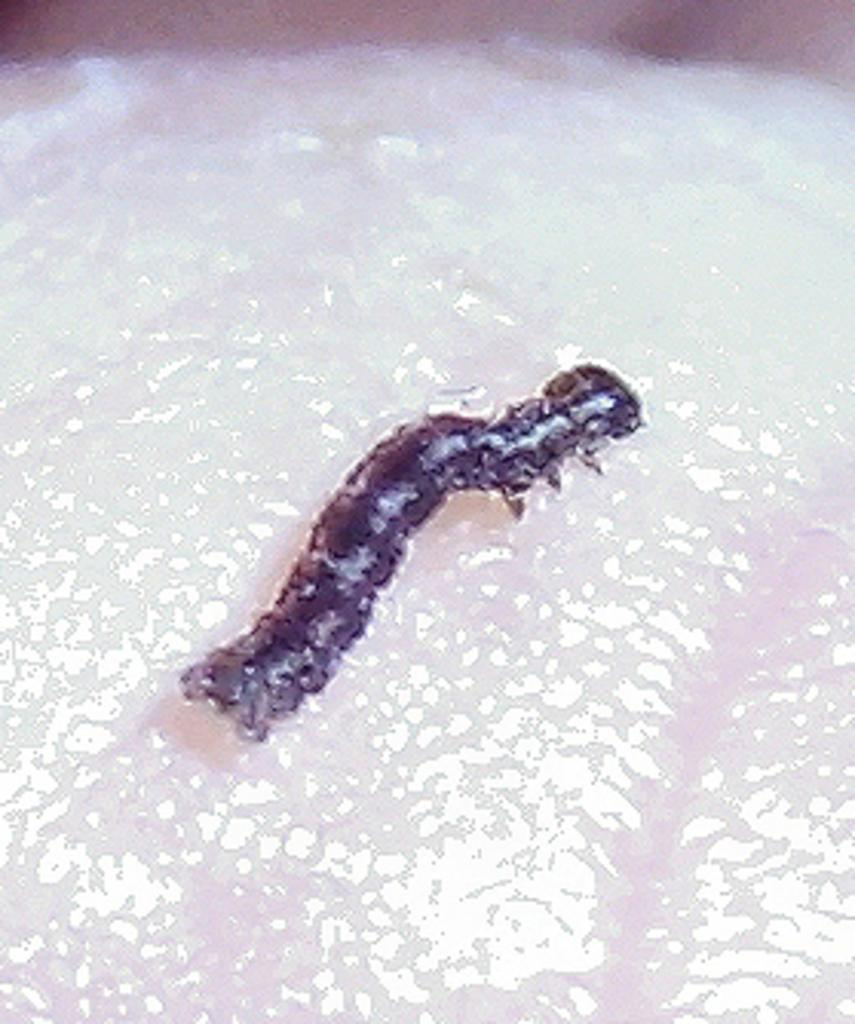What is the main subject of the image? The main subject of the image is a leech. Where is the leech located in the image? The leech is in the center of the image. What is the leech resting on in the image? The leech is on a surface in the image. What type of voice can be heard coming from the leech in the image? There is no sound or voice associated with the leech in the image. What industry is the leech involved in within the image? The image does not depict any industry or business context; it simply shows a leech on a surface. 